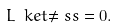<formula> <loc_0><loc_0><loc_500><loc_500>\L L \ k e t { \ne s s } = 0 .</formula> 